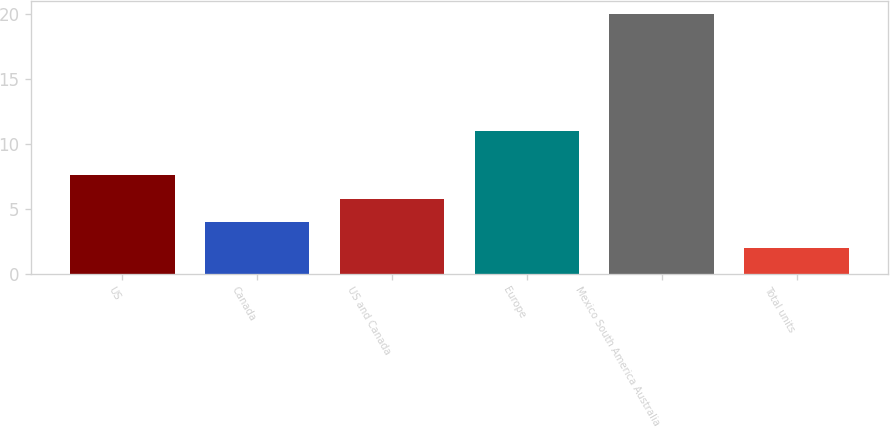Convert chart. <chart><loc_0><loc_0><loc_500><loc_500><bar_chart><fcel>US<fcel>Canada<fcel>US and Canada<fcel>Europe<fcel>Mexico South America Australia<fcel>Total units<nl><fcel>7.6<fcel>4<fcel>5.8<fcel>11<fcel>20<fcel>2<nl></chart> 